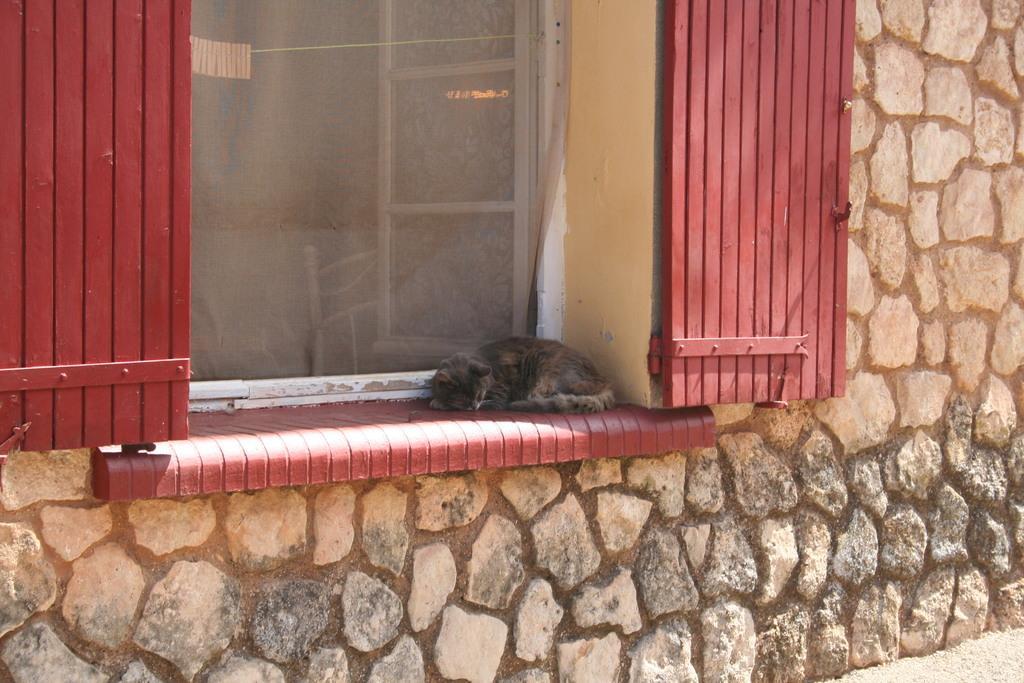Could you give a brief overview of what you see in this image? In this image I can see a cat is sleeping on the window wall. There are window doors in red color to this stone wall. 